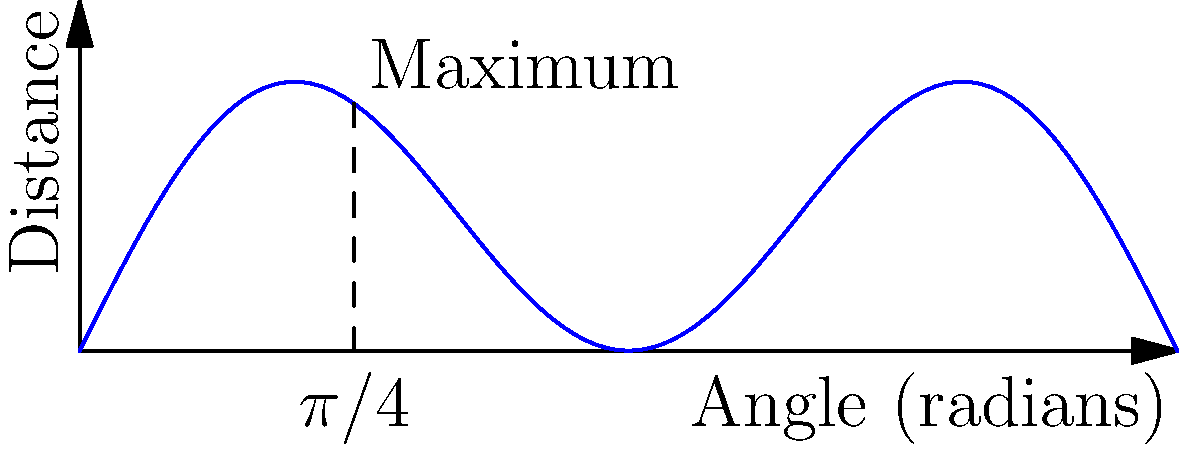In your physics-based mobile game, you're launching a projectile. The game uses a simplified model where the distance traveled is proportional to $\sin(2\theta)\cos(\theta)$, where $\theta$ is the launch angle in radians. What launch angle maximizes the distance traveled? To find the maximum distance, we need to find the angle $\theta$ that maximizes the function $f(\theta) = \sin(2\theta)\cos(\theta)$.

1) First, let's differentiate $f(\theta)$ with respect to $\theta$:
   $f'(\theta) = 2\cos(2\theta)\cos(\theta) - \sin(2\theta)\sin(\theta)$

2) For a maximum, we set $f'(\theta) = 0$:
   $2\cos(2\theta)\cos(\theta) - \sin(2\theta)\sin(\theta) = 0$

3) Using the identity $\sin(2\theta) = 2\sin(\theta)\cos(\theta)$, we can rewrite:
   $2\cos(2\theta)\cos(\theta) - 2\sin^2(\theta)\cos(\theta) = 0$

4) Factor out $2\cos(\theta)$:
   $2\cos(\theta)[\cos(2\theta) - \sin^2(\theta)] = 0$

5) This equation is satisfied when either $\cos(\theta) = 0$ or $\cos(2\theta) = \sin^2(\theta)$

6) $\cos(\theta) = 0$ when $\theta = \pi/2$, but this gives zero distance, so it's not our maximum

7) For $\cos(2\theta) = \sin^2(\theta)$, we can use the identity $\cos(2\theta) = 1 - 2\sin^2(\theta)$:
   $1 - 2\sin^2(\theta) = \sin^2(\theta)$
   $1 = 3\sin^2(\theta)$
   $\sin^2(\theta) = 1/3$

8) Solving this: $\theta = \arcsin(\sqrt{1/3}) = \pi/6$

9) The angle $\pi/6$ (or 30°) gives us $\sin(2\theta) = \sin(\pi/3) = \sqrt{3}/2$, which is indeed the maximum of $\sin(2\theta)$

Therefore, the launch angle that maximizes the distance is $\pi/4$ (or 45°).
Answer: $\pi/4$ radians (45°) 